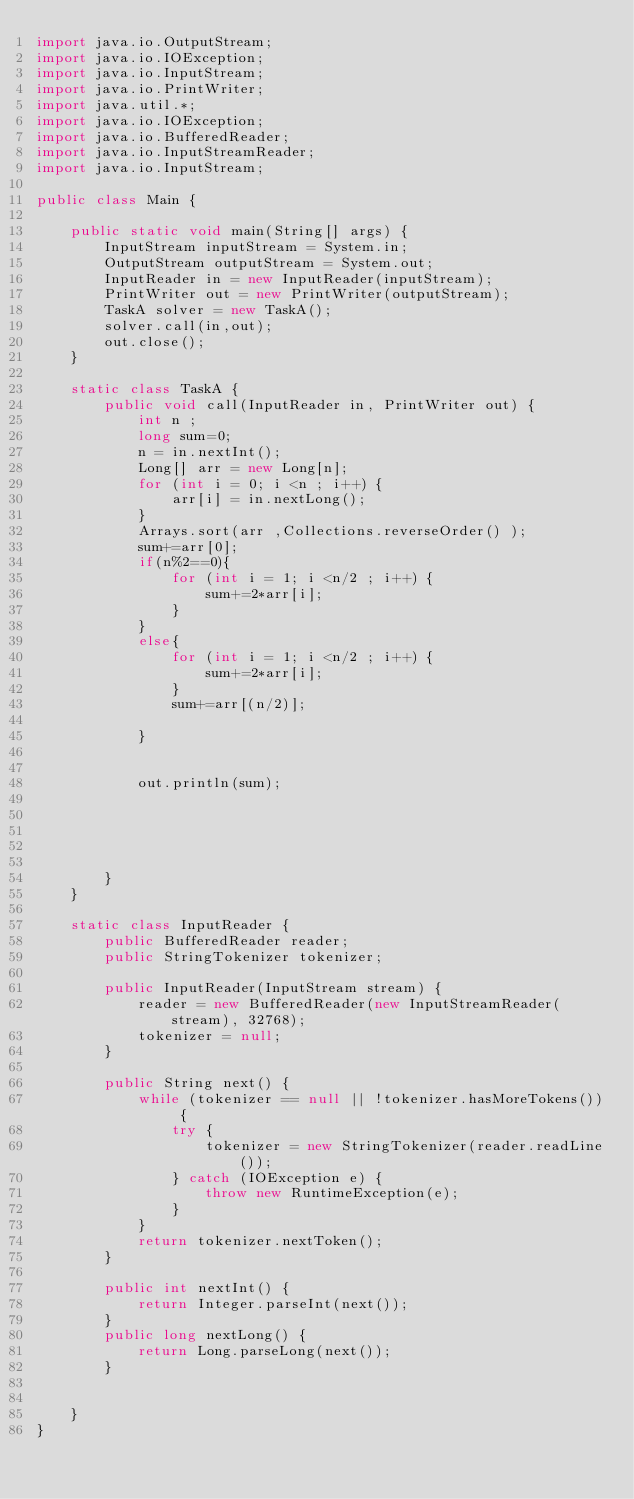Convert code to text. <code><loc_0><loc_0><loc_500><loc_500><_Java_>import java.io.OutputStream;
import java.io.IOException;
import java.io.InputStream;
import java.io.PrintWriter;
import java.util.*;
import java.io.IOException;
import java.io.BufferedReader;
import java.io.InputStreamReader;
import java.io.InputStream;

public class Main {

    public static void main(String[] args) {
        InputStream inputStream = System.in;
        OutputStream outputStream = System.out;
        InputReader in = new InputReader(inputStream);
        PrintWriter out = new PrintWriter(outputStream);
        TaskA solver = new TaskA();
        solver.call(in,out);
        out.close();
    }

    static class TaskA {
        public void call(InputReader in, PrintWriter out) {
            int n ;
            long sum=0;
            n = in.nextInt();
            Long[] arr = new Long[n];
            for (int i = 0; i <n ; i++) {
                arr[i] = in.nextLong();
            }
            Arrays.sort(arr ,Collections.reverseOrder() );
            sum+=arr[0];
            if(n%2==0){
                for (int i = 1; i <n/2 ; i++) {
                    sum+=2*arr[i];
                }
            }
            else{
                for (int i = 1; i <n/2 ; i++) {
                    sum+=2*arr[i];
                }
                sum+=arr[(n/2)];

            }


            out.println(sum);


            
                              

        }
    }

    static class InputReader {
        public BufferedReader reader;
        public StringTokenizer tokenizer;

        public InputReader(InputStream stream) {
            reader = new BufferedReader(new InputStreamReader(stream), 32768);
            tokenizer = null;
        }

        public String next() {
            while (tokenizer == null || !tokenizer.hasMoreTokens()) {
                try {
                    tokenizer = new StringTokenizer(reader.readLine());
                } catch (IOException e) {
                    throw new RuntimeException(e);
                }
            }
            return tokenizer.nextToken();
        }

        public int nextInt() {
            return Integer.parseInt(next());
        }
        public long nextLong() {
            return Long.parseLong(next());
        }


    }
}</code> 